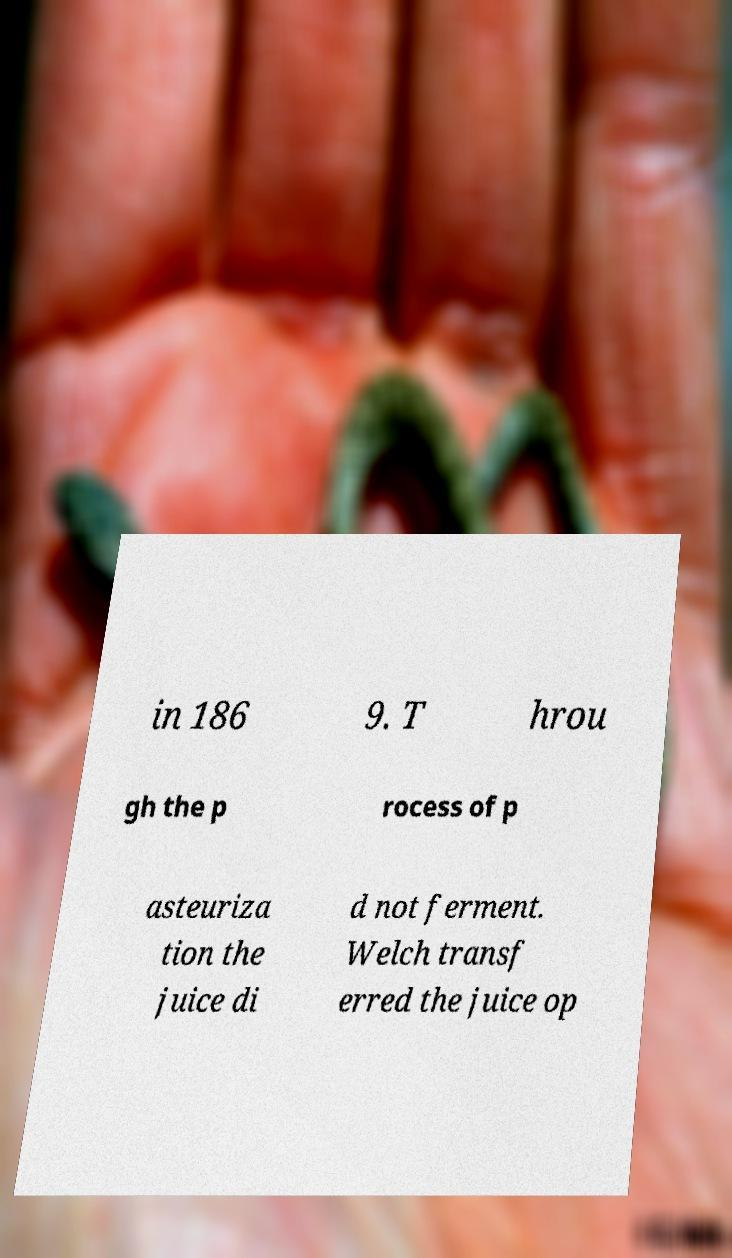Can you read and provide the text displayed in the image?This photo seems to have some interesting text. Can you extract and type it out for me? in 186 9. T hrou gh the p rocess of p asteuriza tion the juice di d not ferment. Welch transf erred the juice op 